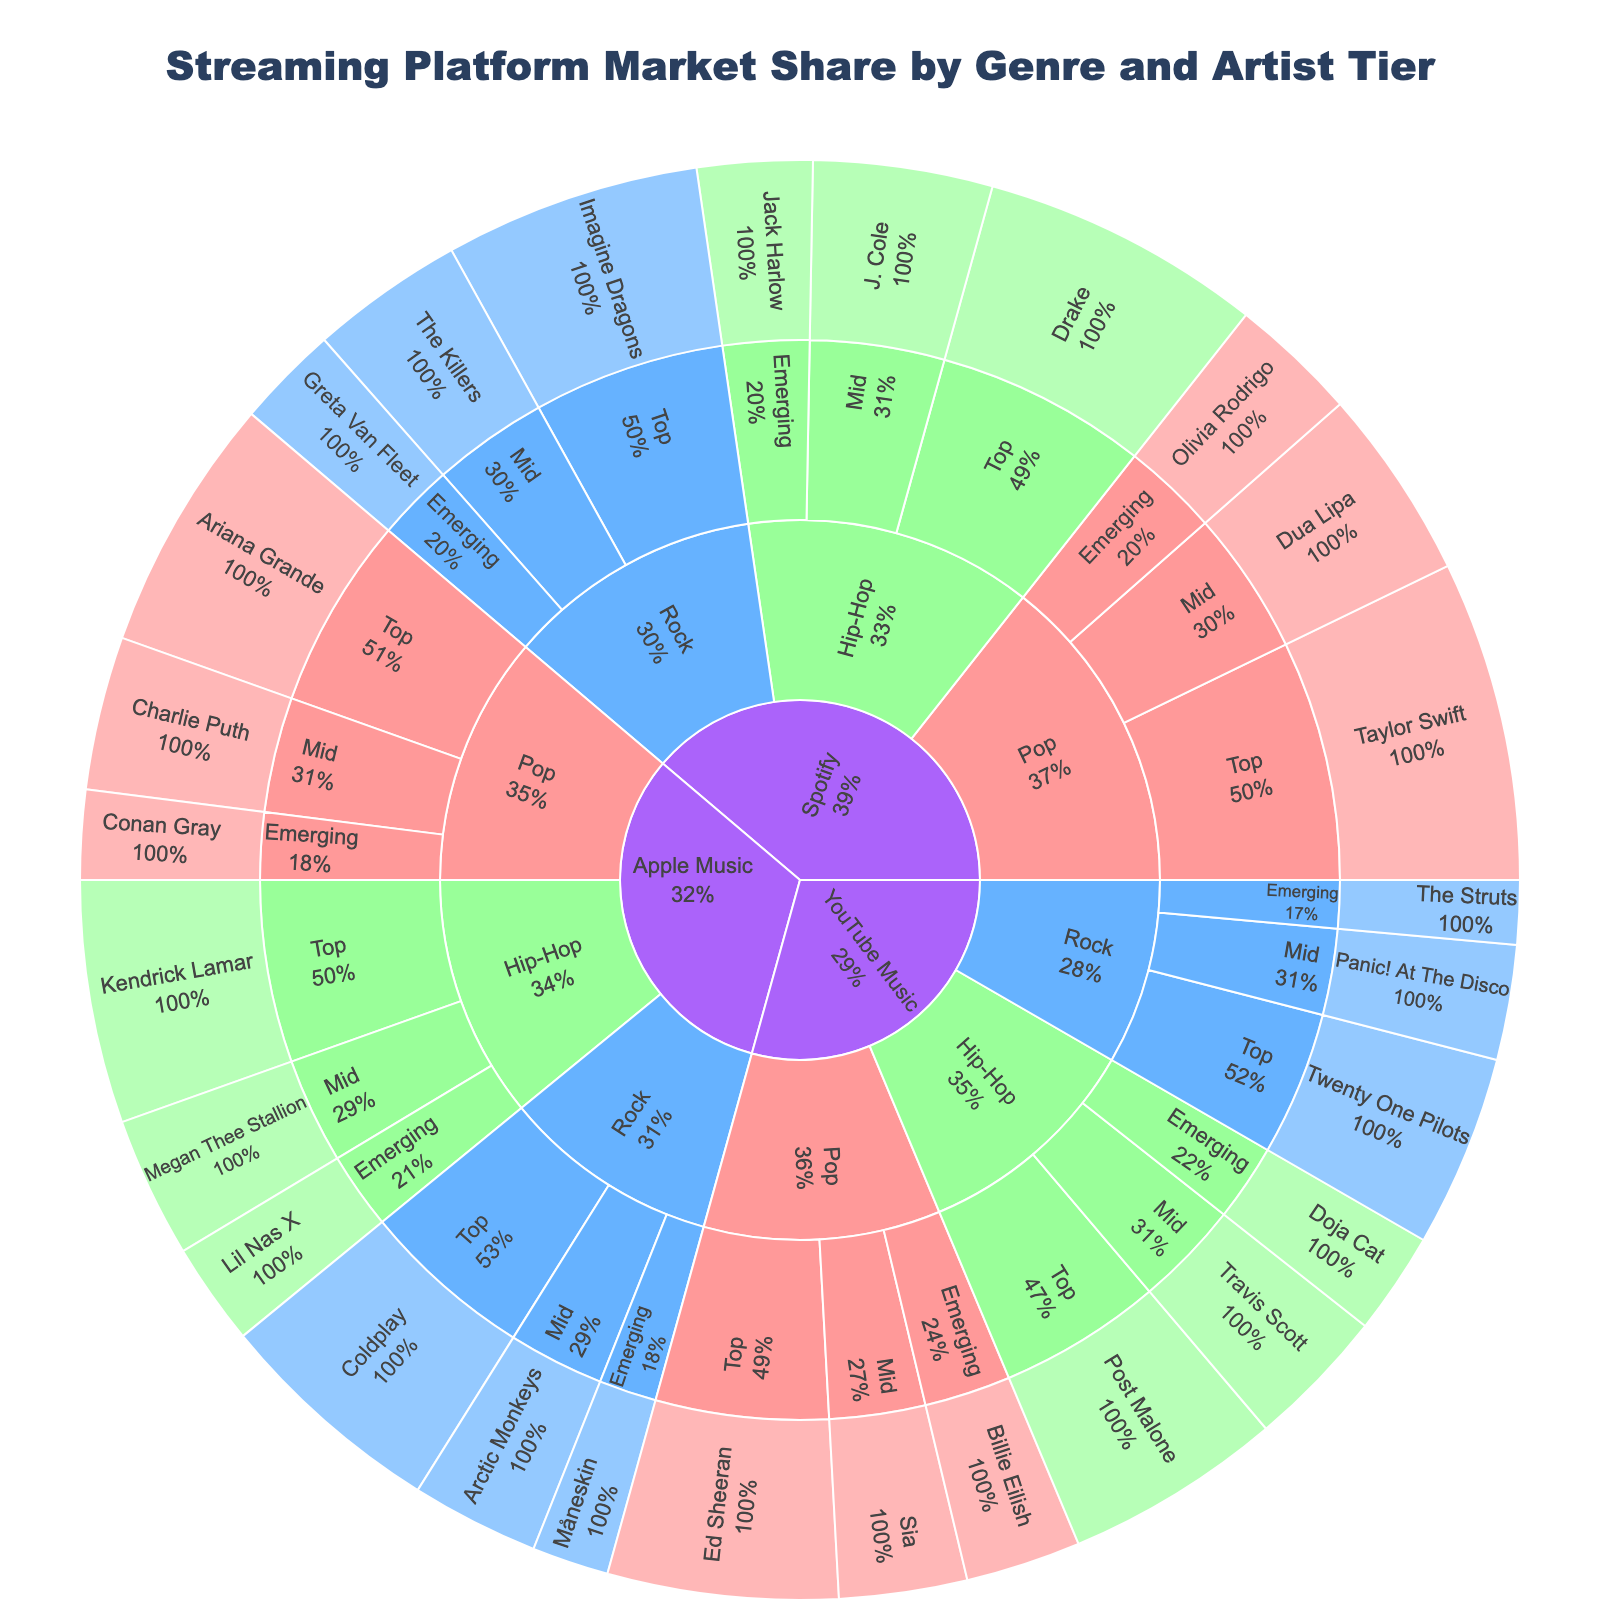what is the title of the sunburst plot? The title of a plot is usually displayed at the top center, providing a summary of the information shown in the plot. In this case, the title is "Streaming Platform Market Share by Genre and Artist Tier."
Answer: Streaming Platform Market Share by Genre and Artist Tier Which genre has the highest market share on Spotify? To determine the genre with the highest market share on Spotify, look at the largest segment under the Spotify section. From the data, Pop has a 50 (25 + 15 + 10) share, Rock has 40 (20 + 12 + 8), and Hip-Hop has 45 (22 + 14 + 9). Thus, Pop has the highest market share on Spotify.
Answer: Pop What's the sum of market shares for all Emerging artists across all platforms? Sum up the values for Emerging artists under each genre and platform: Spotify (10 + 8 + 9), Apple Music (7 + 6 + 8), and YouTube Music (9 + 5 + 8). The sum is 58.
Answer: 58 What fraction of the Spotify Rock genre's market share is contributed by top-tier artists? The total market share of Rock on Spotify is 40, with Top-tier artists contributing 20. The fraction is 20/40, which simplifies to 1/2 or 50%.
Answer: 50% Compare the market share of Dua Lipa on Spotify to that of Sia on YouTube Music. Who has a larger share? Dua Lipa's market share on Spotify is 15, while Sia's share on YouTube Music is 10. Comparing these two values, Dua Lipa has a larger market share.
Answer: Dua Lipa Calculate the average market share for the Top-tier Hip-Hop artists across all platforms. Sum the values for Top-tier Hip-Hop artists: Spotify (22), Apple Music (19), YouTube Music (17), which totals to 58. There are three data points, so the average is 58/3 = 19.33.
Answer: 19.33 Which platform has a greater market share in the Pop genre: Apple Music or YouTube Music? Apple Music's Pop shares are 20 (Top) + 12 (Mid) + 7 (Emerging) totaling 39. YouTube Music's Pop shares are 18 (Top) + 10 (Mid) + 9 (Emerging) totaling 37. Apple Music has a greater market share in the Pop genre.
Answer: Apple Music Identify the artist with the smallest market share on YouTube Music and state the value. The smallest value under YouTube Music across all tiers and genres is The Struts in Rock, with a market share of 5.
Answer: The Struts, 5 How does the market share of Top Pop artists on Spotify compare to that on Apple Music? Spotify Top Pop artists have a market share of 25, while Apple Music Top Pop artists have a share of 20. Thus, Spotify has a larger market share for Top Pop artists.
Answer: Spotify What is the combined market share of all genres on YouTube Music? Combine the total market shares for Pop, Rock, and Hip-Hop on YouTube Music: Pop (18 + 10 + 9 = 37), Rock (15 + 9 + 5 = 29), and Hip-Hop (17 + 11 + 8 = 36). The combined market share is 37 + 29 + 36 = 102.
Answer: 102 